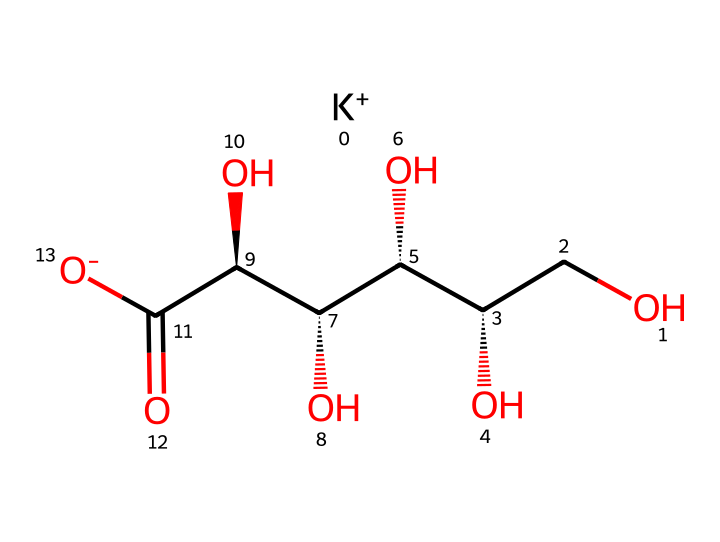What is the molecular formula of potassium gluconate? The molecular formula can be derived from the structural representation, identifying the elements and their respective counts. From the structure, we have 1 potassium (K), 6 carbons (C), 12 hydrogens (H), and 7 oxygens (O), leading to the formula C6H11O7K.
Answer: C6H11O7K How many carbon atoms are present in potassium gluconate? By analyzing the skeletal structure, we can count the carbon atoms. The structure shows that there are 6 carbon atoms branching throughout the molecule.
Answer: 6 What type of functional groups are present in potassium gluconate? Observing the structure reveals both a carboxylic acid group (-COOH) at one end and multiple hydroxyl groups (-OH) attached to the carbon chains, identifying it as having both -COOH and -OH functional groups.
Answer: carboxylic acid and hydroxyl groups How many stereocenters does potassium gluconate have? A stereocenter is typically a carbon attached to four different substituents. In the structure, we see that there are three such carbons (C2, C3, and C4) that meet this criterion, indicating the presence of three stereocenters.
Answer: 3 What role does potassium play in this electrolyte? In the structure, potassium (K+) is shown as a charged ion, which signifies that it serves as an electrolyte, crucial for maintaining electrical balance and hydration within the body of pets.
Answer: electrolyte What does the presence of multiple hydroxyl groups indicate about potassium gluconate? The multiple hydroxyl groups suggest that potassium gluconate is highly soluble in water, enhancing its properties as an electrolyte supplement as it can readily dissolve and dissociate to provide ions in solution.
Answer: high solubility in water Which part of this chemical structure represents its ionic character? The presence of the potassium ion (K+) at the beginning of the structure indicates the ionic character of potassium gluconate, as it dissociates in solution contributing to its function as an electrolyte.
Answer: potassium ion 